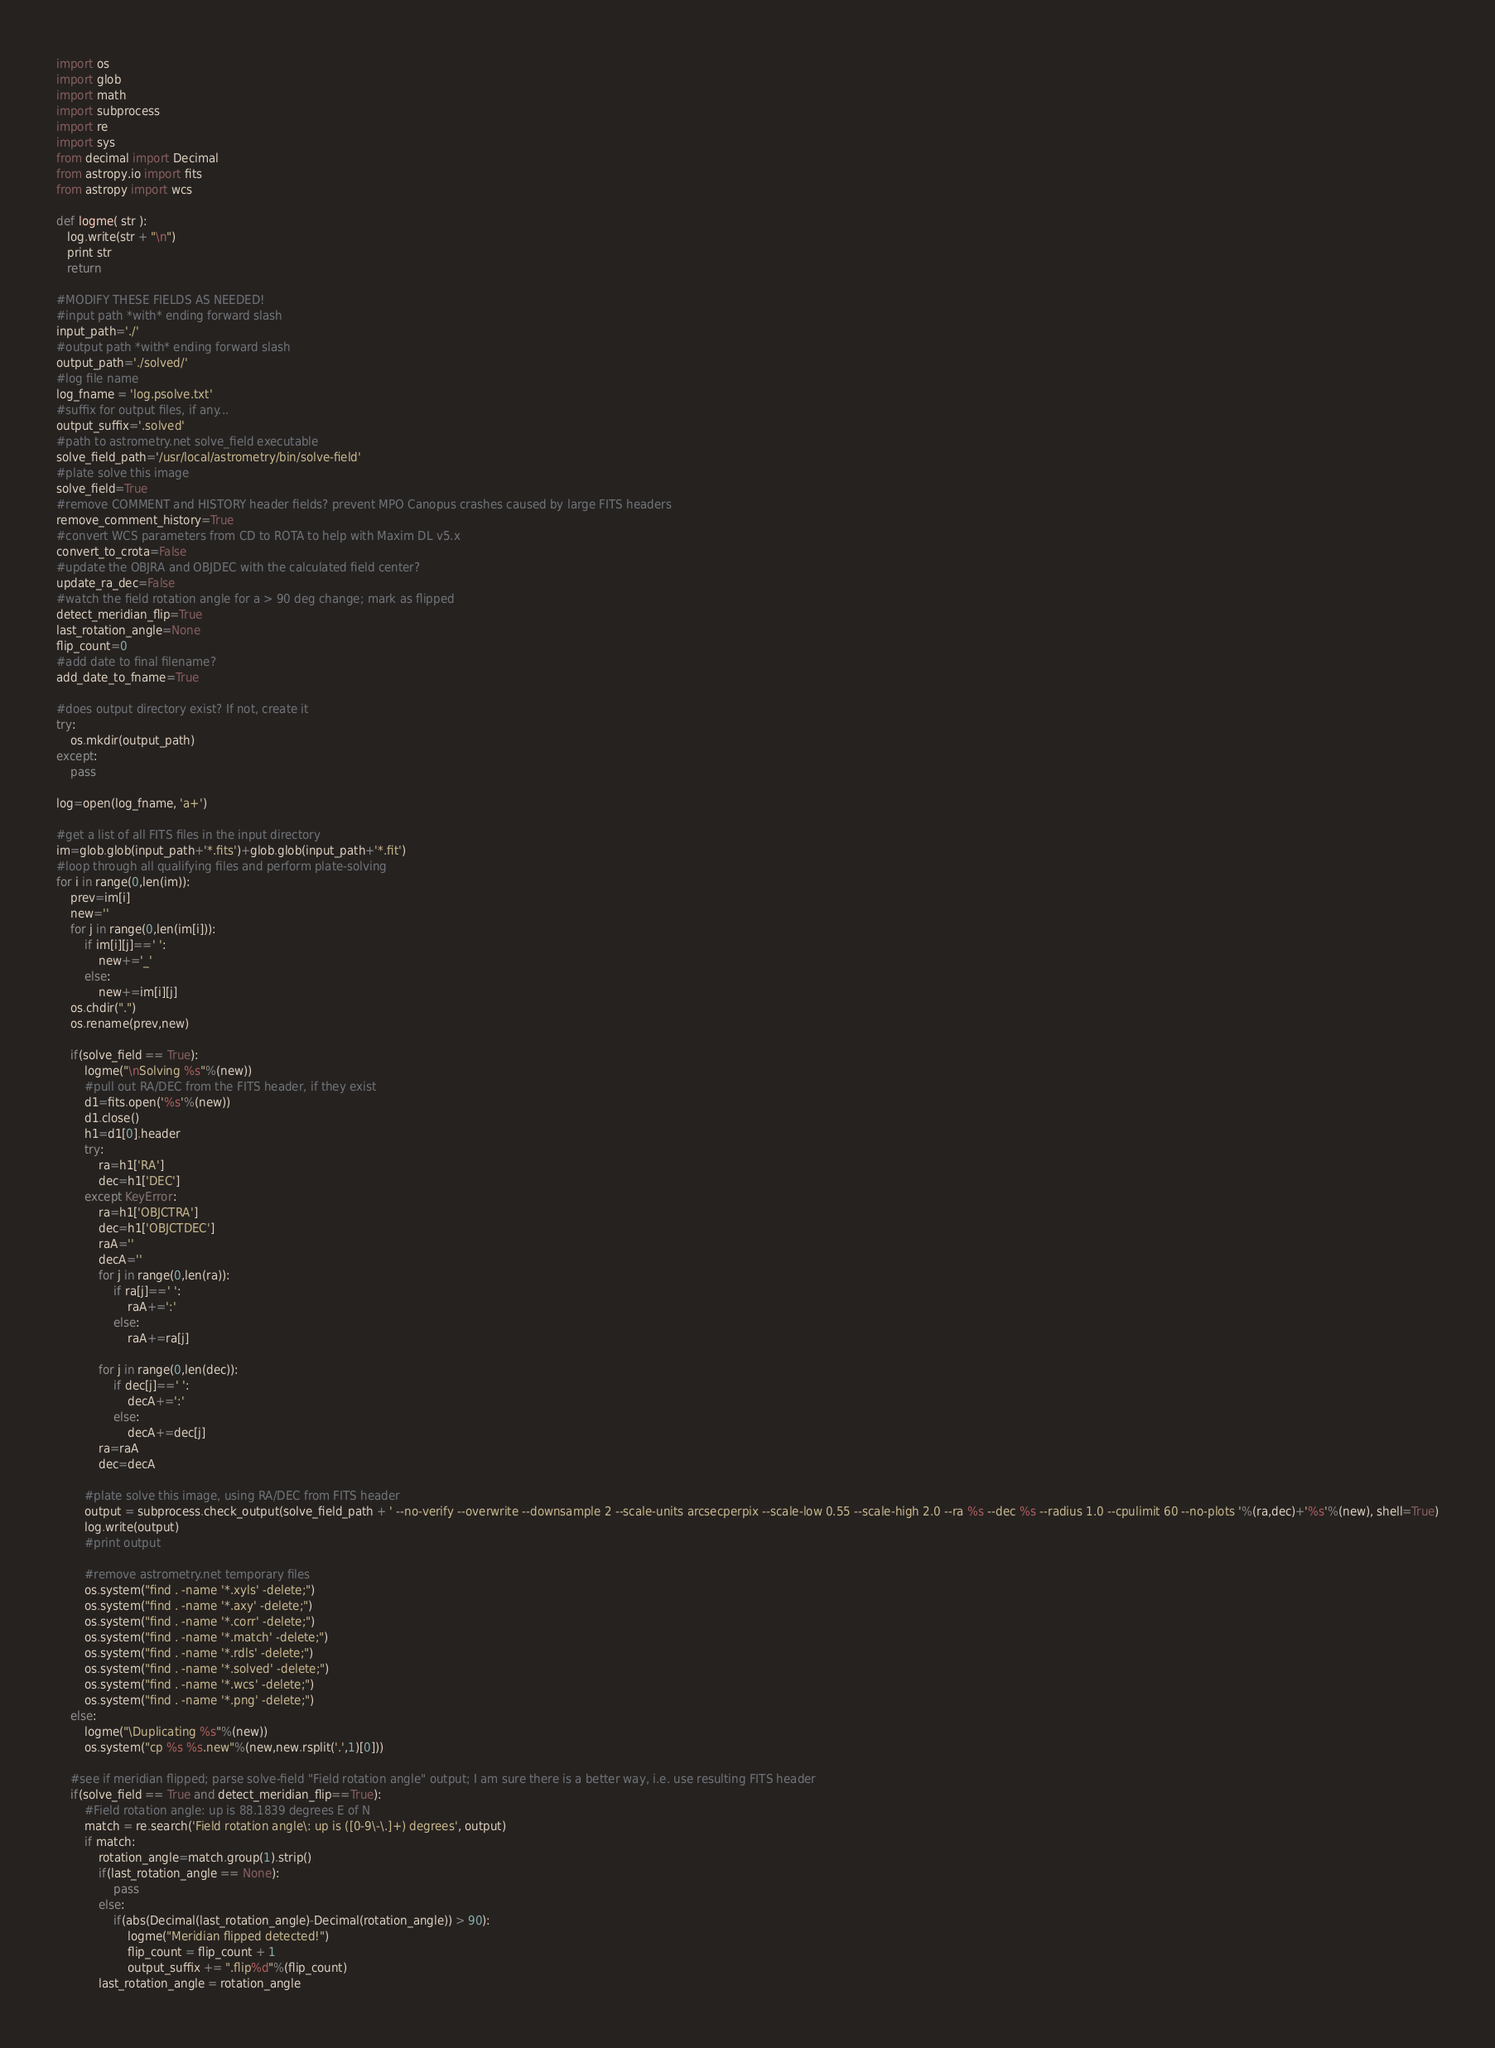<code> <loc_0><loc_0><loc_500><loc_500><_Python_>import os
import glob
import math
import subprocess
import re
import sys
from decimal import Decimal
from astropy.io import fits
from astropy import wcs

def logme( str ):
   log.write(str + "\n")
   print str
   return

#MODIFY THESE FIELDS AS NEEDED!
#input path *with* ending forward slash
input_path='./'
#output path *with* ending forward slash
output_path='./solved/'
#log file name
log_fname = 'log.psolve.txt'
#suffix for output files, if any...
output_suffix='.solved'
#path to astrometry.net solve_field executable
solve_field_path='/usr/local/astrometry/bin/solve-field'
#plate solve this image
solve_field=True
#remove COMMENT and HISTORY header fields? prevent MPO Canopus crashes caused by large FITS headers
remove_comment_history=True
#convert WCS parameters from CD to ROTA to help with Maxim DL v5.x
convert_to_crota=False
#update the OBJRA and OBJDEC with the calculated field center?
update_ra_dec=False
#watch the field rotation angle for a > 90 deg change; mark as flipped
detect_meridian_flip=True
last_rotation_angle=None
flip_count=0
#add date to final filename?
add_date_to_fname=True

#does output directory exist? If not, create it
try:
    os.mkdir(output_path)
except:
    pass

log=open(log_fname, 'a+')	
    
#get a list of all FITS files in the input directory	
im=glob.glob(input_path+'*.fits')+glob.glob(input_path+'*.fit')
#loop through all qualifying files and perform plate-solving
for i in range(0,len(im)):
    prev=im[i]
    new=''
    for j in range(0,len(im[i])):
        if im[i][j]==' ':
            new+='_'
        else:
            new+=im[i][j]			
    os.chdir(".")
    os.rename(prev,new)
    
    if(solve_field == True):
        logme("\nSolving %s"%(new))
        #pull out RA/DEC from the FITS header, if they exist
        d1=fits.open('%s'%(new))
        d1.close()
        h1=d1[0].header
        try:
            ra=h1['RA']
            dec=h1['DEC']
        except KeyError:
            ra=h1['OBJCTRA']
            dec=h1['OBJCTDEC']
            raA=''
            decA=''
            for j in range(0,len(ra)):
                if ra[j]==' ':
                    raA+=':'
                else:
                    raA+=ra[j]

            for j in range(0,len(dec)):
                if dec[j]==' ':
                    decA+=':'
                else:
                    decA+=dec[j]
            ra=raA
            dec=decA
        
        #plate solve this image, using RA/DEC from FITS header
        output = subprocess.check_output(solve_field_path + ' --no-verify --overwrite --downsample 2 --scale-units arcsecperpix --scale-low 0.55 --scale-high 2.0 --ra %s --dec %s --radius 1.0 --cpulimit 60 --no-plots '%(ra,dec)+'%s'%(new), shell=True)
        log.write(output)
        #print output
        
        #remove astrometry.net temporary files
        os.system("find . -name '*.xyls' -delete;")
        os.system("find . -name '*.axy' -delete;")
        os.system("find . -name '*.corr' -delete;")
        os.system("find . -name '*.match' -delete;")
        os.system("find . -name '*.rdls' -delete;")
        os.system("find . -name '*.solved' -delete;")
        os.system("find . -name '*.wcs' -delete;")
        os.system("find . -name '*.png' -delete;")
    else:
        logme("\Duplicating %s"%(new))
        os.system("cp %s %s.new"%(new,new.rsplit('.',1)[0]))
    
    #see if meridian flipped; parse solve-field "Field rotation angle" output; I am sure there is a better way, i.e. use resulting FITS header
    if(solve_field == True and detect_meridian_flip==True):
        #Field rotation angle: up is 88.1839 degrees E of N
        match = re.search('Field rotation angle\: up is ([0-9\-\.]+) degrees', output)	
        if match:
            rotation_angle=match.group(1).strip()
            if(last_rotation_angle == None):
                pass
            else:
                if(abs(Decimal(last_rotation_angle)-Decimal(rotation_angle)) > 90):
                    logme("Meridian flipped detected!")
                    flip_count = flip_count + 1
                    output_suffix += ".flip%d"%(flip_count)
            last_rotation_angle = rotation_angle				</code> 